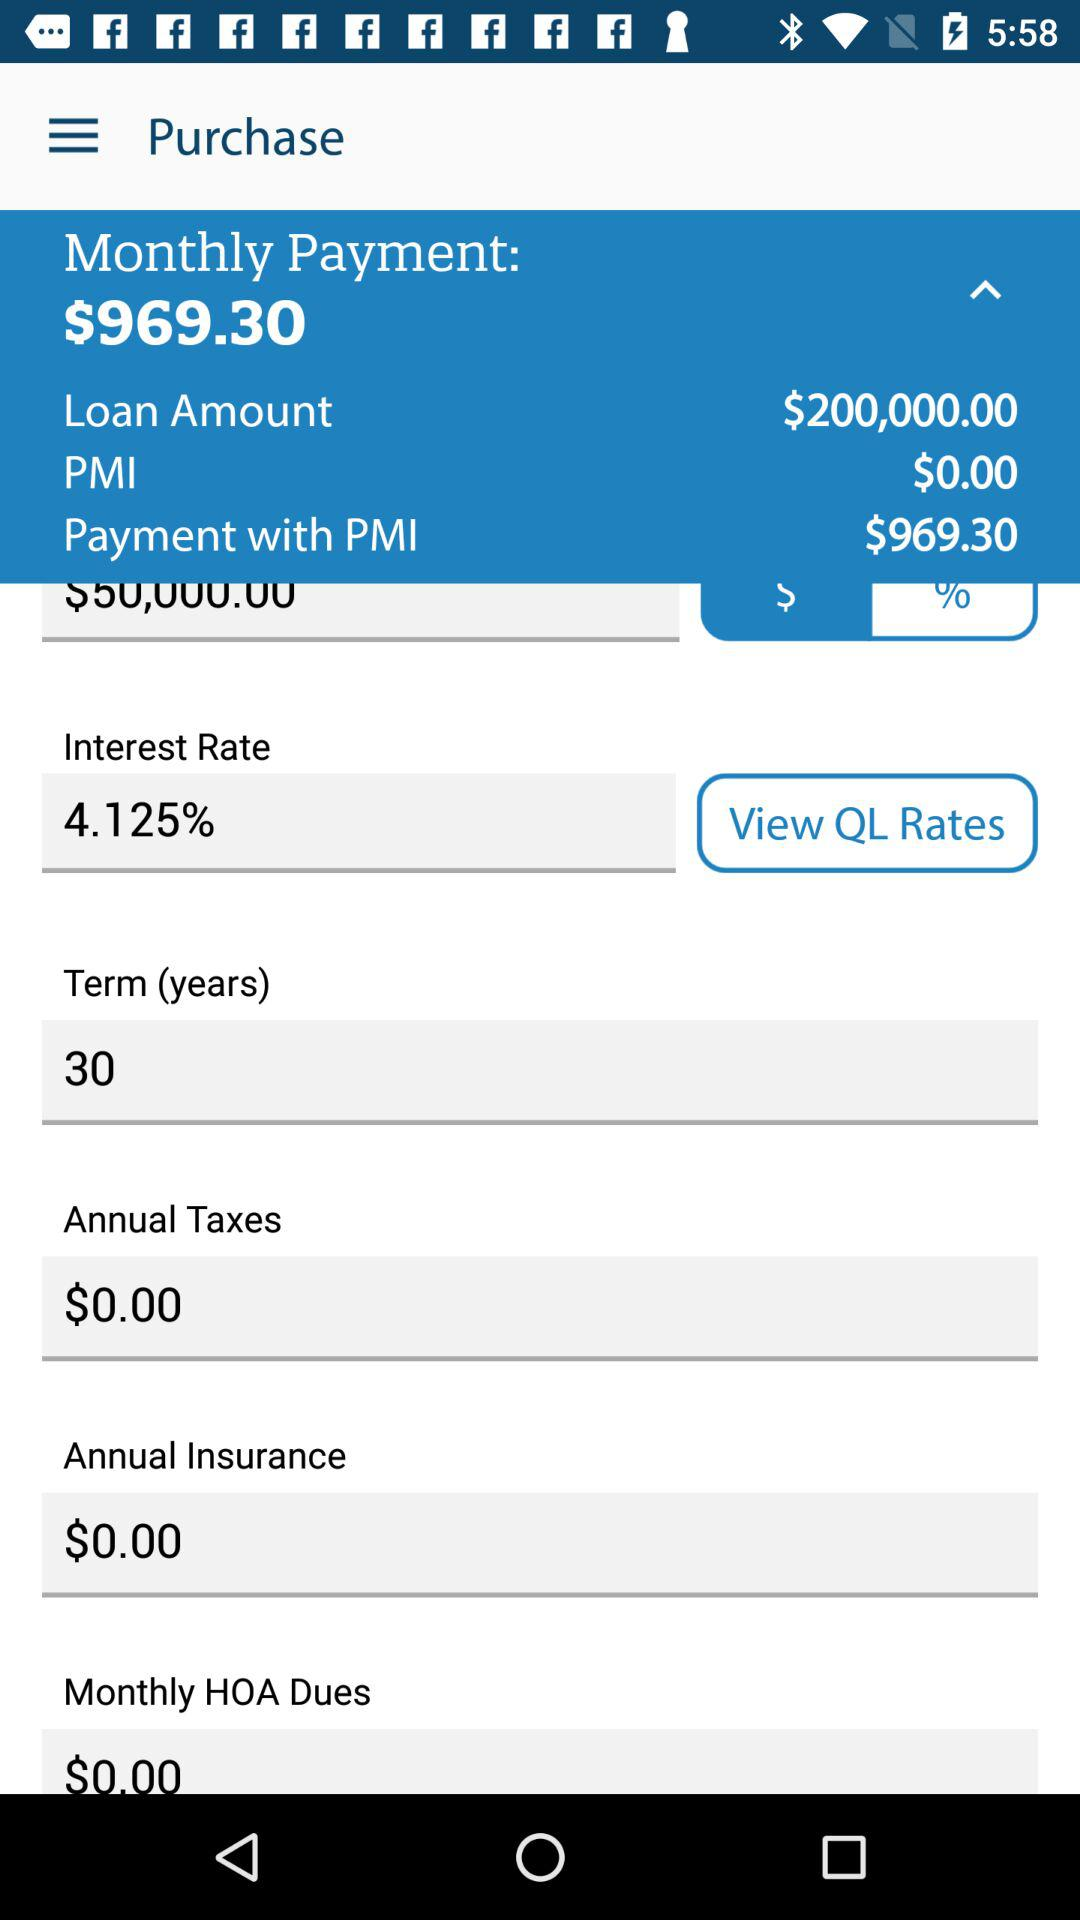What is the loan amount? The loan amount is $200,000.00. 